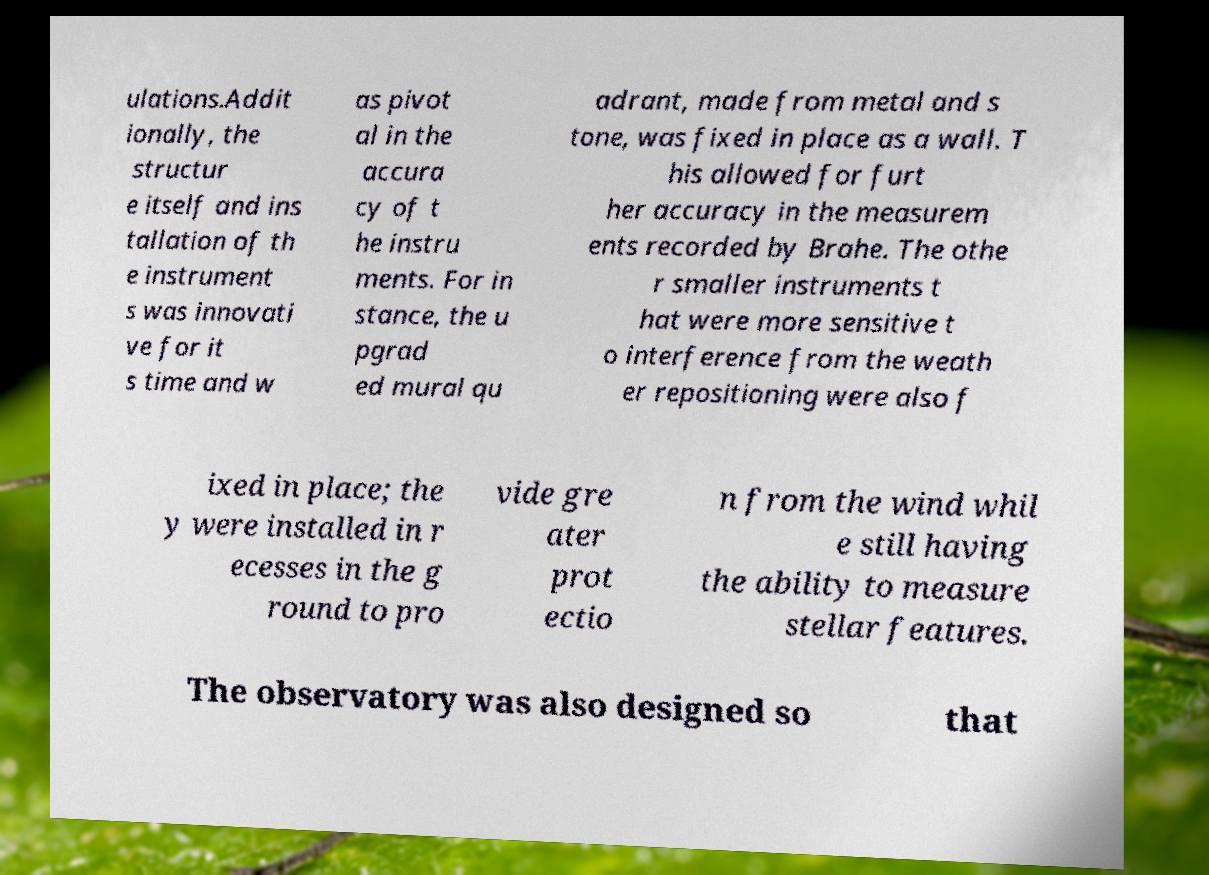What messages or text are displayed in this image? I need them in a readable, typed format. ulations.Addit ionally, the structur e itself and ins tallation of th e instrument s was innovati ve for it s time and w as pivot al in the accura cy of t he instru ments. For in stance, the u pgrad ed mural qu adrant, made from metal and s tone, was fixed in place as a wall. T his allowed for furt her accuracy in the measurem ents recorded by Brahe. The othe r smaller instruments t hat were more sensitive t o interference from the weath er repositioning were also f ixed in place; the y were installed in r ecesses in the g round to pro vide gre ater prot ectio n from the wind whil e still having the ability to measure stellar features. The observatory was also designed so that 